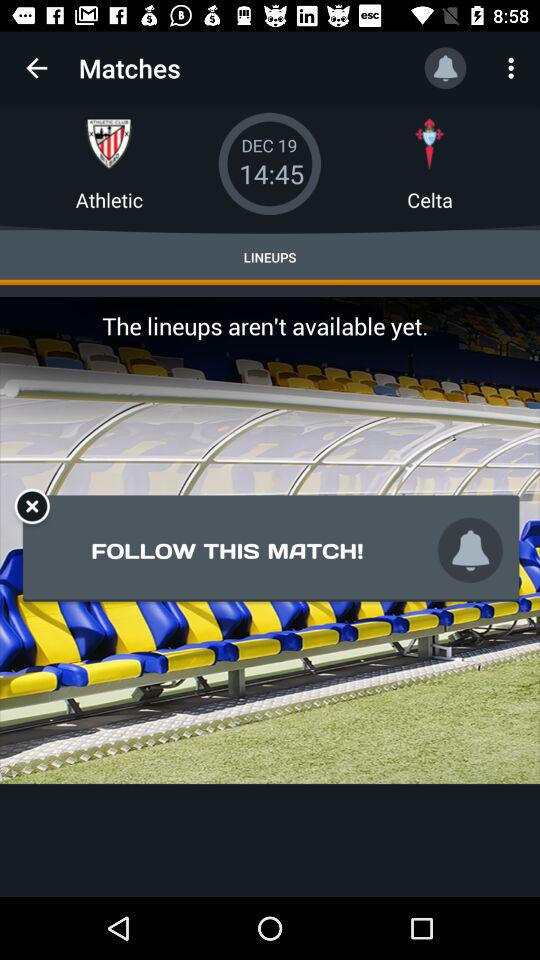How many teams are playing in the match?
Answer the question using a single word or phrase. 2 